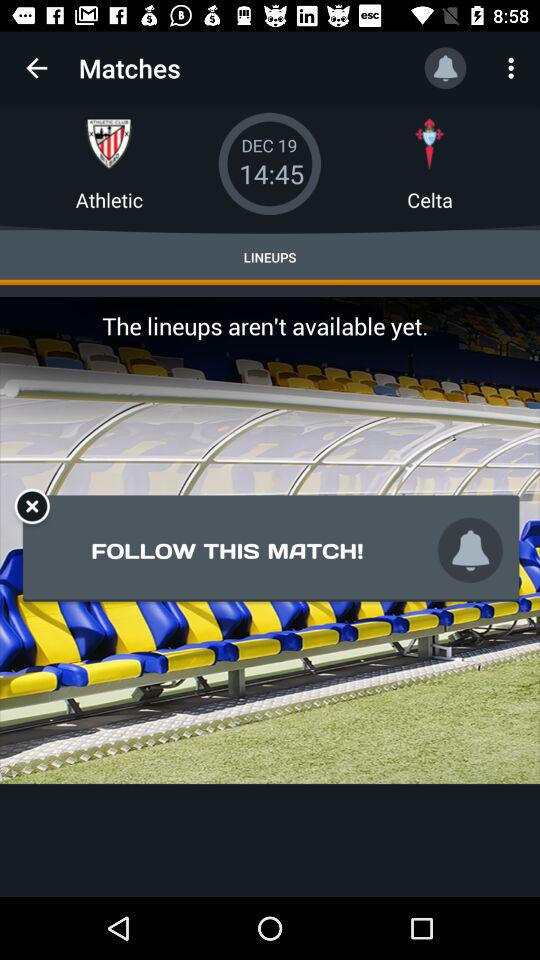How many teams are playing in the match?
Answer the question using a single word or phrase. 2 